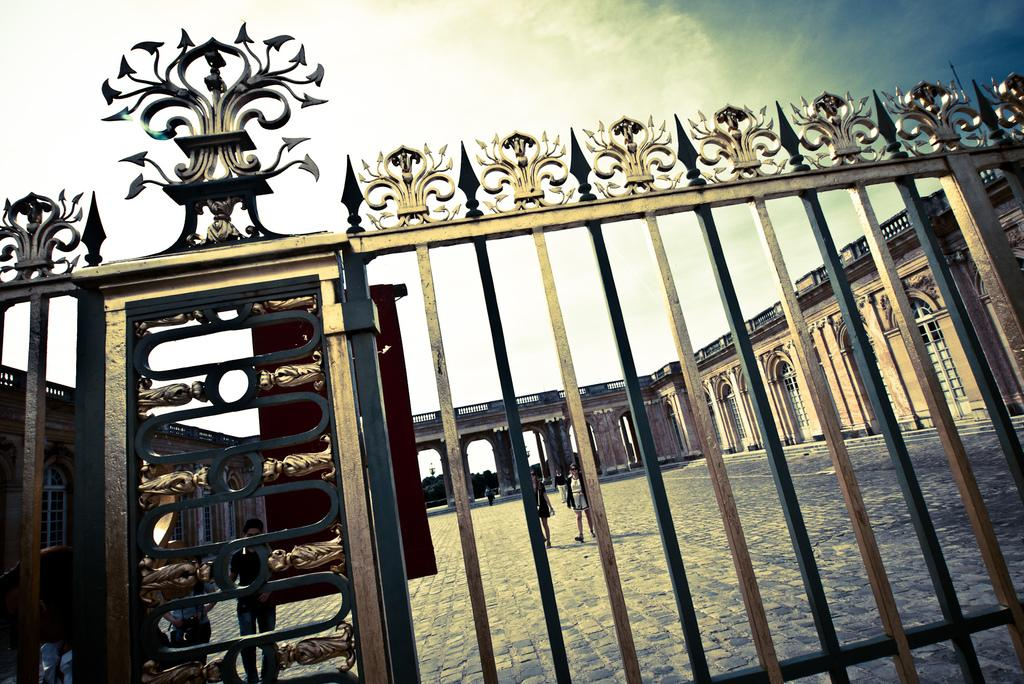What type of barrier can be seen in the image? There is a fence in the image. How would you describe the weather based on the image? The sky is cloudy in the image. What is located behind the fence? There is a wall visible behind the fence. What features are present on the wall? Windows and doors are visible on the wall. Are there any people in the image? Yes, there are people near the wall. What type of structure is present in the image that allows people or vehicles to cross over a gap? There is a bridge in the image. What type of roof can be seen on the bear in the image? There is no bear present in the image, and therefore no roof on a bear can be observed. What is the friction between the ice cream and the cone in the image? There is no ice cream or cone present in the image, so friction between them cannot be determined. 